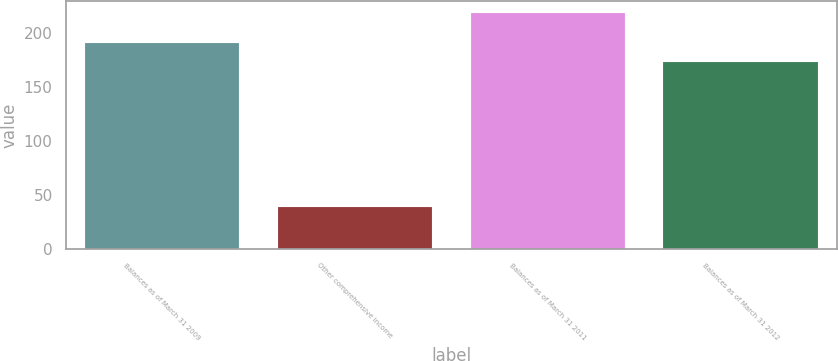Convert chart to OTSL. <chart><loc_0><loc_0><loc_500><loc_500><bar_chart><fcel>Balances as of March 31 2009<fcel>Other comprehensive income<fcel>Balances as of March 31 2011<fcel>Balances as of March 31 2012<nl><fcel>191<fcel>39<fcel>219<fcel>173<nl></chart> 